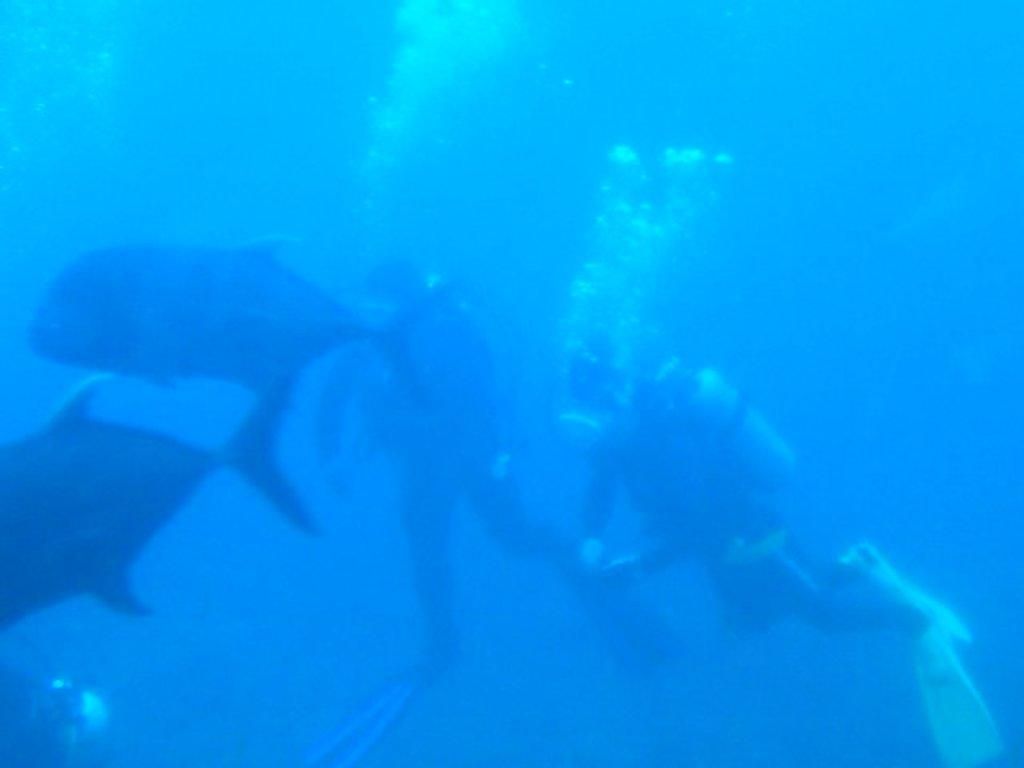What are the two people in the image doing? The two people in the image are swimming in the water. What else can be seen swimming in the water? There are two fish swimming in the water. What is visible in the background of the image? There is water visible in the background. What type of popcorn can be seen floating in the water? There is no popcorn present in the image; it features two people and two fish swimming in the water. Is there any smoke visible in the image? No, there is no smoke visible in the image. 